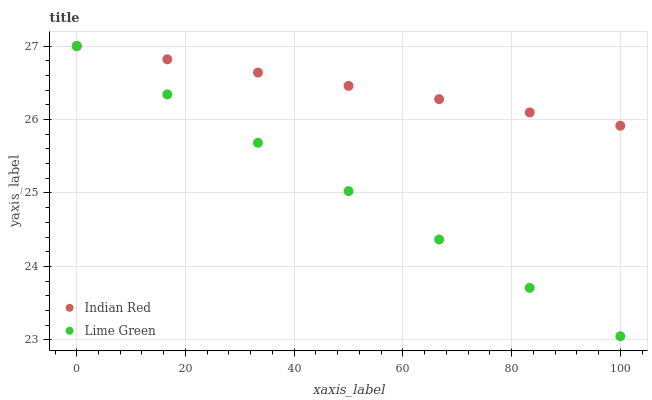Does Lime Green have the minimum area under the curve?
Answer yes or no. Yes. Does Indian Red have the maximum area under the curve?
Answer yes or no. Yes. Does Indian Red have the minimum area under the curve?
Answer yes or no. No. Is Indian Red the smoothest?
Answer yes or no. Yes. Is Lime Green the roughest?
Answer yes or no. Yes. Is Indian Red the roughest?
Answer yes or no. No. Does Lime Green have the lowest value?
Answer yes or no. Yes. Does Indian Red have the lowest value?
Answer yes or no. No. Does Indian Red have the highest value?
Answer yes or no. Yes. Does Indian Red intersect Lime Green?
Answer yes or no. Yes. Is Indian Red less than Lime Green?
Answer yes or no. No. Is Indian Red greater than Lime Green?
Answer yes or no. No. 